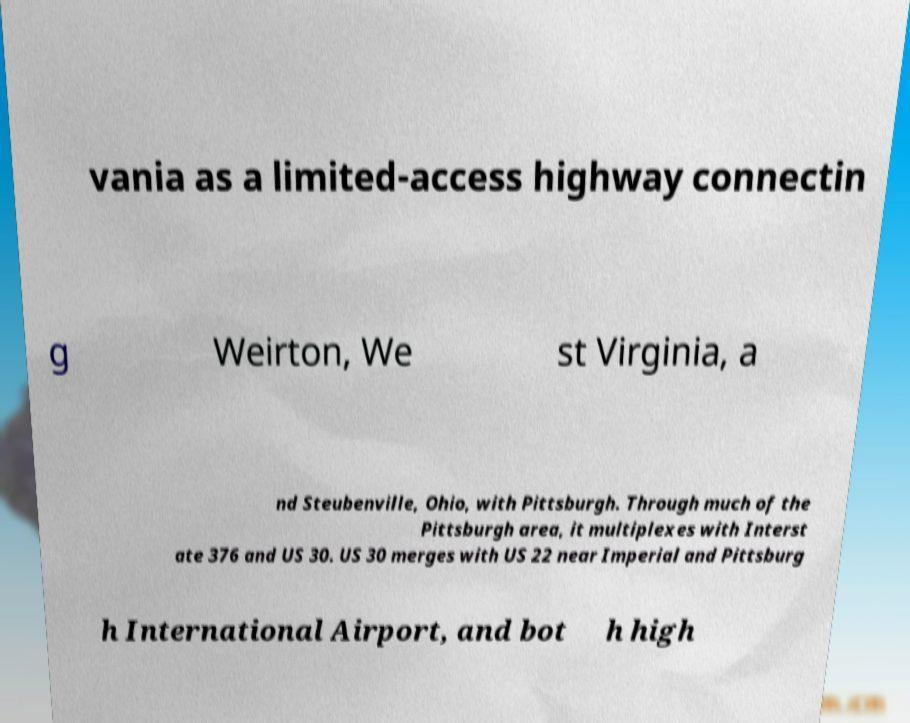For documentation purposes, I need the text within this image transcribed. Could you provide that? vania as a limited-access highway connectin g Weirton, We st Virginia, a nd Steubenville, Ohio, with Pittsburgh. Through much of the Pittsburgh area, it multiplexes with Interst ate 376 and US 30. US 30 merges with US 22 near Imperial and Pittsburg h International Airport, and bot h high 